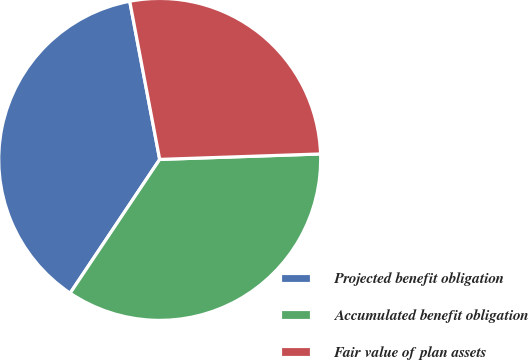<chart> <loc_0><loc_0><loc_500><loc_500><pie_chart><fcel>Projected benefit obligation<fcel>Accumulated benefit obligation<fcel>Fair value of plan assets<nl><fcel>37.63%<fcel>34.93%<fcel>27.44%<nl></chart> 